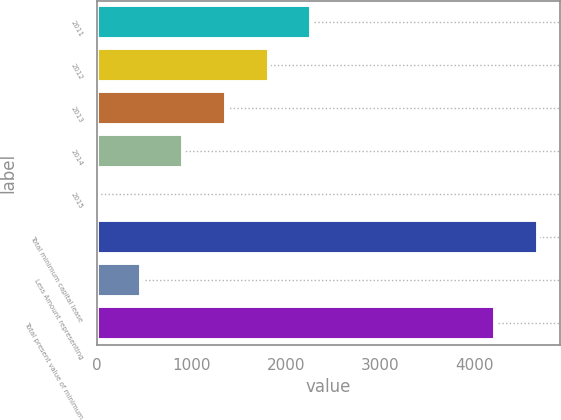<chart> <loc_0><loc_0><loc_500><loc_500><bar_chart><fcel>2011<fcel>2012<fcel>2013<fcel>2014<fcel>2015<fcel>Total minimum capital lease<fcel>Less Amount representing<fcel>Total present value of minimum<nl><fcel>2269.5<fcel>1817.8<fcel>1366.1<fcel>914.4<fcel>11<fcel>4670.7<fcel>462.7<fcel>4219<nl></chart> 